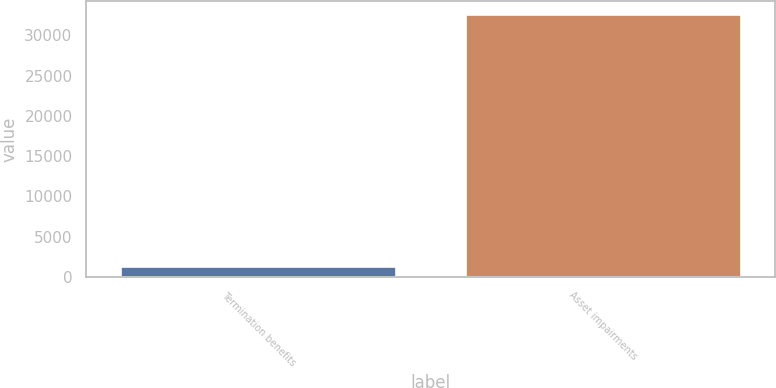Convert chart to OTSL. <chart><loc_0><loc_0><loc_500><loc_500><bar_chart><fcel>Termination benefits<fcel>Asset impairments<nl><fcel>1388<fcel>32662<nl></chart> 